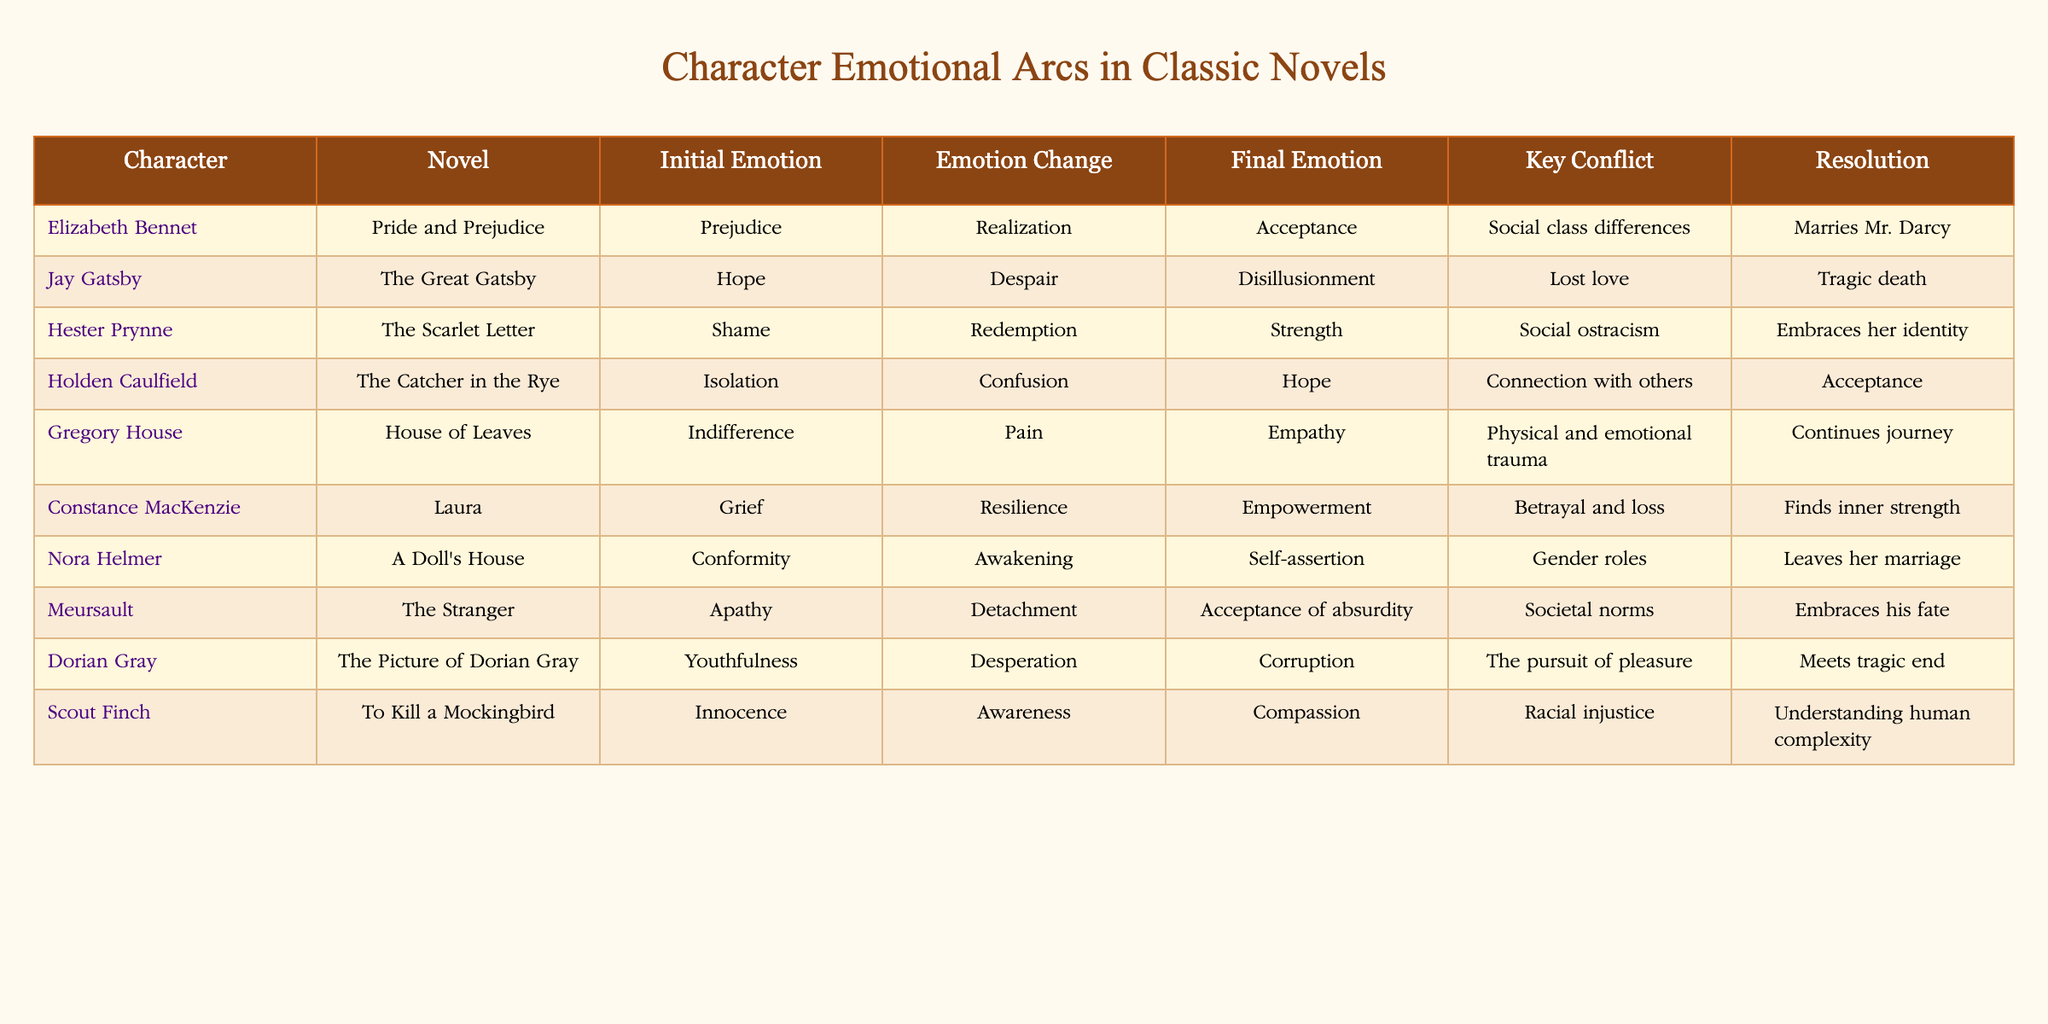What is the initial emotion of Jay Gatsby? The table specifies that Jay Gatsby's initial emotion is "Hope." This is found directly in the row corresponding to his character in the table.
Answer: Hope Which character ends with the emotion of Acceptance? Looking through the final emotions column, both Holden Caulfield and Meursault have "Acceptance" as their final emotion. Thus, multiple characters fit this criterion.
Answer: Holden Caulfield, Meursault What key conflict did Elizabeth Bennet face? The key conflict for Elizabeth Bennet is listed in her row as "Social class differences." This is a direct reference from the table, identifying the primary challenge of her emotional arc.
Answer: Social class differences Does Hester Prynne achieve a final emotion of Strength? No, the table indicates that Hester Prynne's final emotion is "Strength," but her path involved shame and redemption first. Therefore, she does reach a final emotional state of strength.
Answer: No What is the difference between the initial and final emotions of Dorian Gray? The initial emotion of Dorian Gray is "Youthfulness" and his final emotion is "Corruption." Calculating this difference involves identifying first the nature of the sentiments, which show a significant change: from the optimistic nature of youthfulness to the negative state of corruption.
Answer: Significant change Who among the characters underwent the most significant transformation in emotions based on the table? Examining the changes in emotions: Jay Gatsby shifts from "Hope" to "Disillusionment," Hester Prynne moves from "Shame" to "Strength," while Dorian Gray experiences a transition from "Youthfulness" to "Corruption." The most drastic transformation is noted in Gatsby’s arc, given the emotional contrast between hope and tragic disillusionment.
Answer: Jay Gatsby How many characters experienced a final emotional state of Acceptance? The table shows that two characters, Holden Caulfield and Meursault, end with the emotion of Acceptance. This means there are a total of two characters who experience this final emotional state.
Answer: Two What was Constance MacKenzie’s key conflict? According to the table, Constance MacKenzie's key conflict is identified as "Betrayal and loss." This is directly extracted from her row in the table.
Answer: Betrayal and loss What emotional change did Scout Finch undergo throughout her journey? Scout Finch’s emotional journey is depicted as starting from "Innocence," transitioning to "Awareness," and culminating in "Compassion." This progression indicates her growth through experiences of racial injustice, showcasing a complex emotional development.
Answer: Innocence to Compassion 